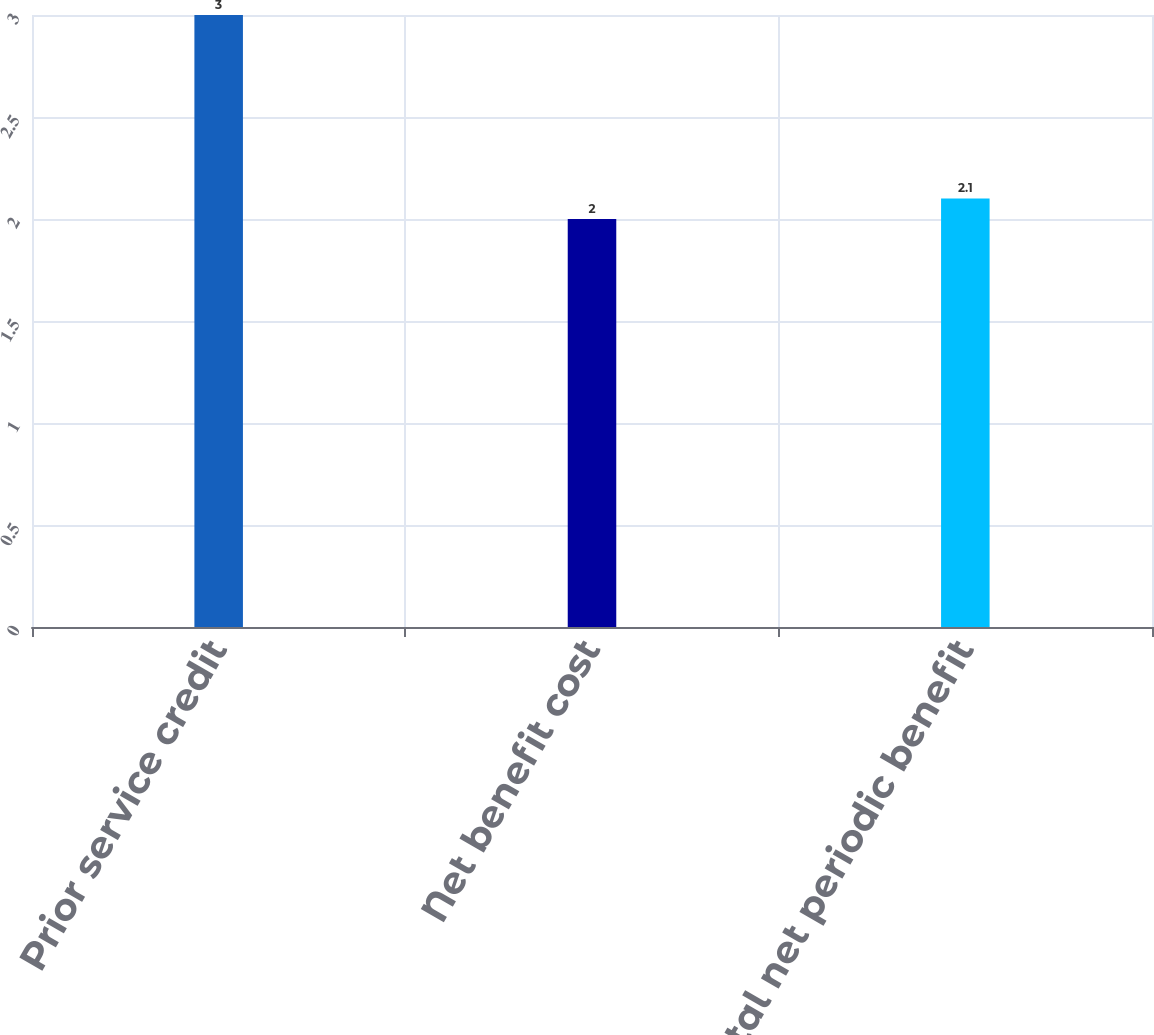<chart> <loc_0><loc_0><loc_500><loc_500><bar_chart><fcel>Prior service credit<fcel>Net benefit cost<fcel>Total net periodic benefit<nl><fcel>3<fcel>2<fcel>2.1<nl></chart> 